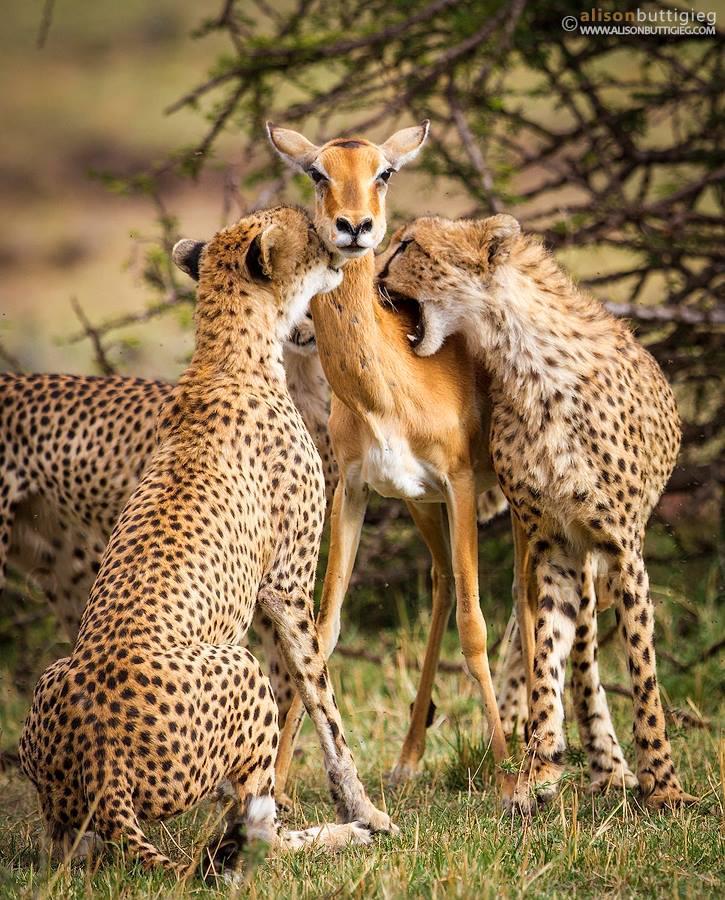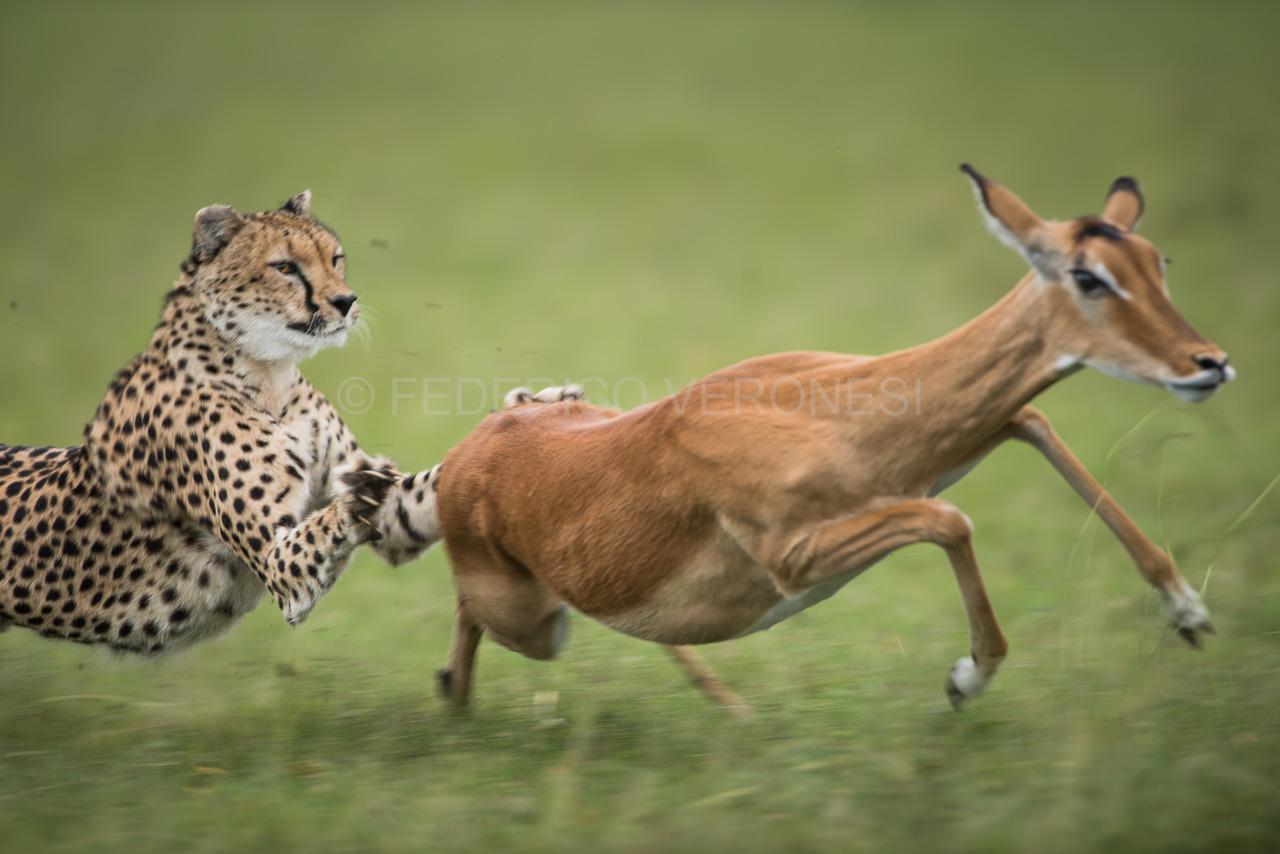The first image is the image on the left, the second image is the image on the right. Evaluate the accuracy of this statement regarding the images: "One leopard is chasing a young deer while another leopard will have antelope for the meal.". Is it true? Answer yes or no. No. 